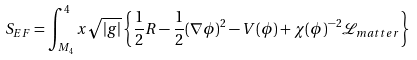<formula> <loc_0><loc_0><loc_500><loc_500>& S _ { E F } = \int _ { M _ { 4 } } ^ { 4 } x \sqrt { | g | } \left \{ \frac { 1 } { 2 } R - \frac { 1 } { 2 } ( \nabla \phi ) ^ { 2 } - V ( \phi ) + \chi ( \phi ) ^ { - 2 } \mathcal { L } _ { m a t t e r } \right \}</formula> 